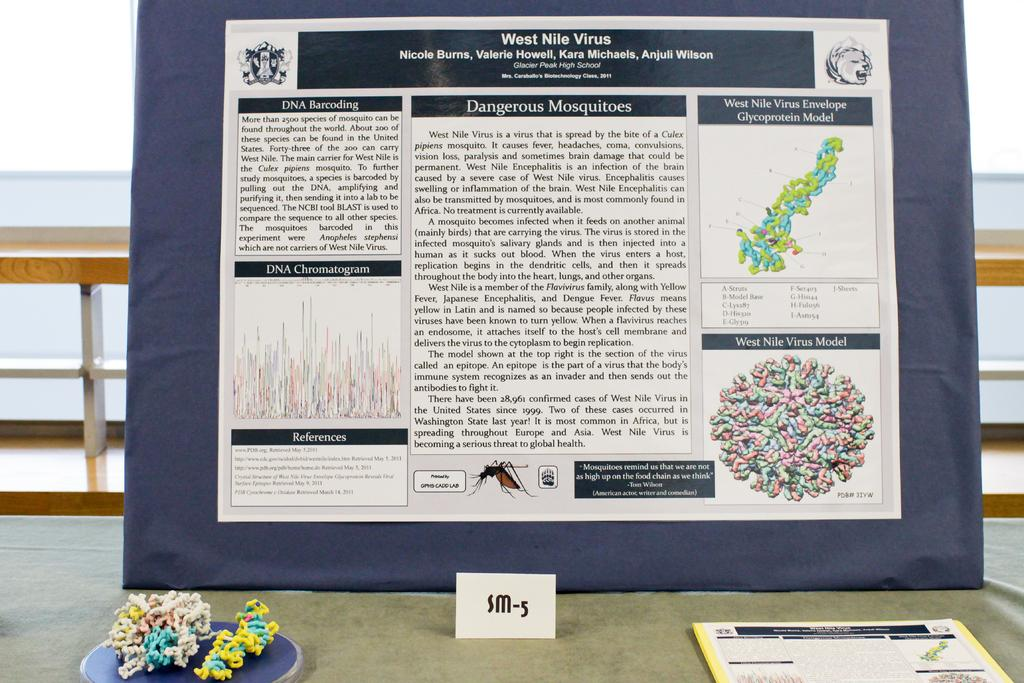<image>
Create a compact narrative representing the image presented. Presentation that has a white sign that says "SM-5". 